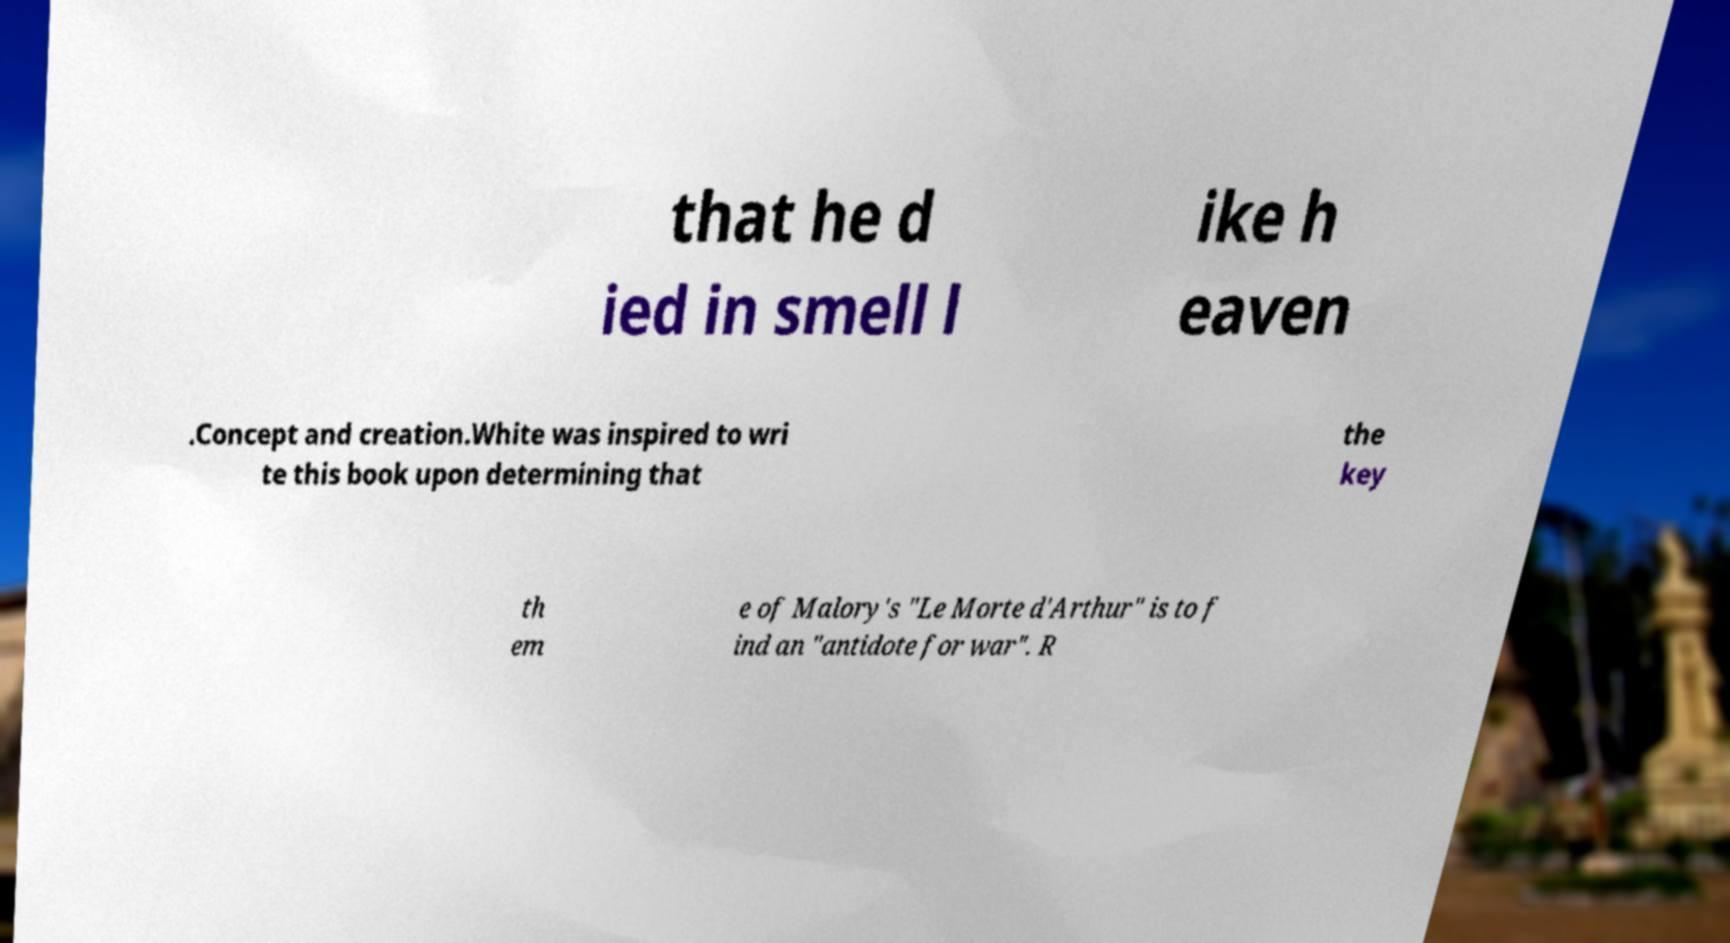What messages or text are displayed in this image? I need them in a readable, typed format. that he d ied in smell l ike h eaven .Concept and creation.White was inspired to wri te this book upon determining that the key th em e of Malory's "Le Morte d'Arthur" is to f ind an "antidote for war". R 